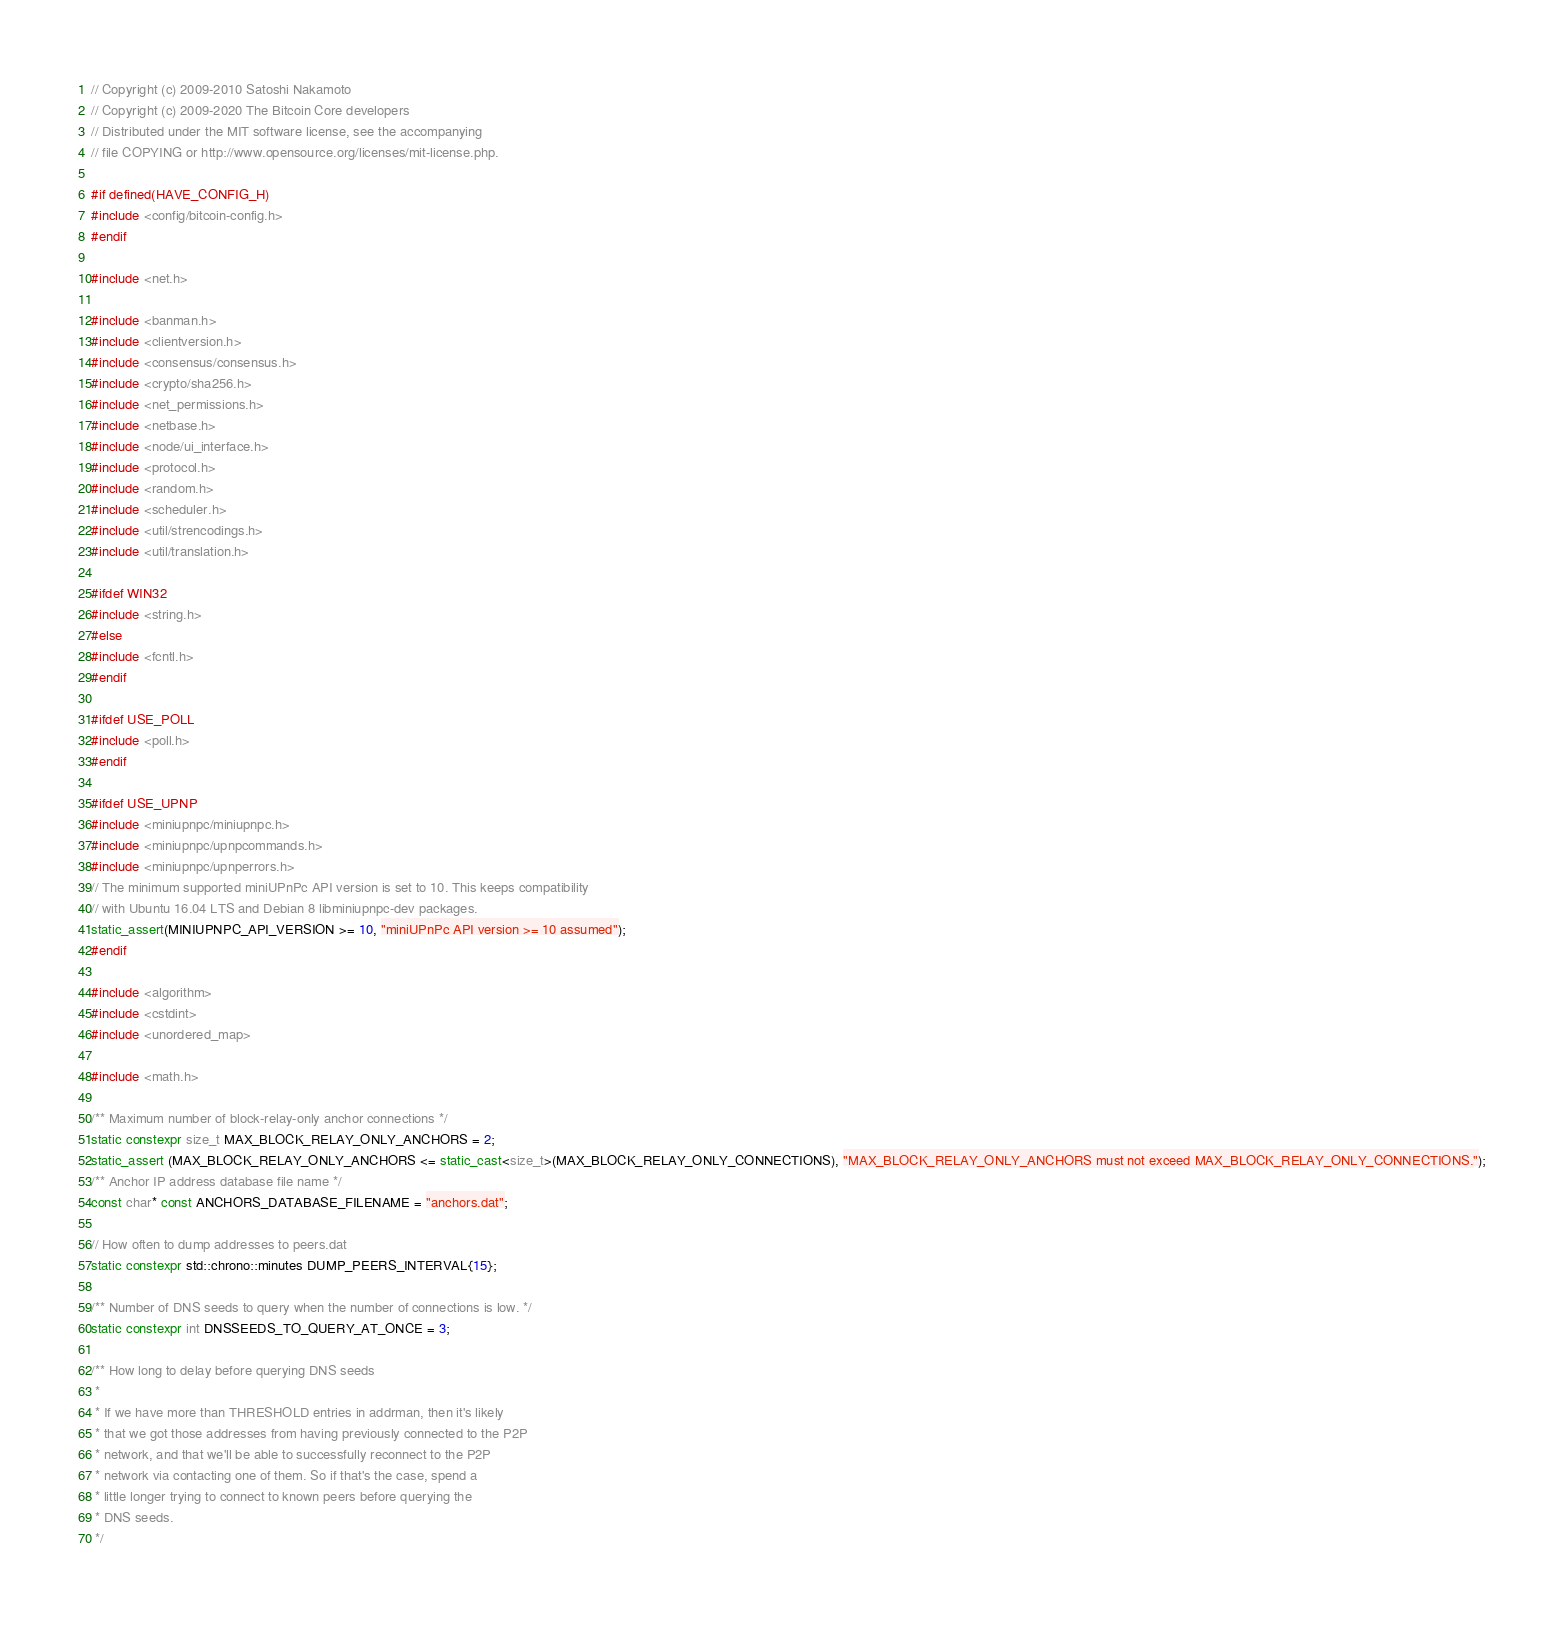<code> <loc_0><loc_0><loc_500><loc_500><_C++_>// Copyright (c) 2009-2010 Satoshi Nakamoto
// Copyright (c) 2009-2020 The Bitcoin Core developers
// Distributed under the MIT software license, see the accompanying
// file COPYING or http://www.opensource.org/licenses/mit-license.php.

#if defined(HAVE_CONFIG_H)
#include <config/bitcoin-config.h>
#endif

#include <net.h>

#include <banman.h>
#include <clientversion.h>
#include <consensus/consensus.h>
#include <crypto/sha256.h>
#include <net_permissions.h>
#include <netbase.h>
#include <node/ui_interface.h>
#include <protocol.h>
#include <random.h>
#include <scheduler.h>
#include <util/strencodings.h>
#include <util/translation.h>

#ifdef WIN32
#include <string.h>
#else
#include <fcntl.h>
#endif

#ifdef USE_POLL
#include <poll.h>
#endif

#ifdef USE_UPNP
#include <miniupnpc/miniupnpc.h>
#include <miniupnpc/upnpcommands.h>
#include <miniupnpc/upnperrors.h>
// The minimum supported miniUPnPc API version is set to 10. This keeps compatibility
// with Ubuntu 16.04 LTS and Debian 8 libminiupnpc-dev packages.
static_assert(MINIUPNPC_API_VERSION >= 10, "miniUPnPc API version >= 10 assumed");
#endif

#include <algorithm>
#include <cstdint>
#include <unordered_map>

#include <math.h>

/** Maximum number of block-relay-only anchor connections */
static constexpr size_t MAX_BLOCK_RELAY_ONLY_ANCHORS = 2;
static_assert (MAX_BLOCK_RELAY_ONLY_ANCHORS <= static_cast<size_t>(MAX_BLOCK_RELAY_ONLY_CONNECTIONS), "MAX_BLOCK_RELAY_ONLY_ANCHORS must not exceed MAX_BLOCK_RELAY_ONLY_CONNECTIONS.");
/** Anchor IP address database file name */
const char* const ANCHORS_DATABASE_FILENAME = "anchors.dat";

// How often to dump addresses to peers.dat
static constexpr std::chrono::minutes DUMP_PEERS_INTERVAL{15};

/** Number of DNS seeds to query when the number of connections is low. */
static constexpr int DNSSEEDS_TO_QUERY_AT_ONCE = 3;

/** How long to delay before querying DNS seeds
 *
 * If we have more than THRESHOLD entries in addrman, then it's likely
 * that we got those addresses from having previously connected to the P2P
 * network, and that we'll be able to successfully reconnect to the P2P
 * network via contacting one of them. So if that's the case, spend a
 * little longer trying to connect to known peers before querying the
 * DNS seeds.
 */</code> 